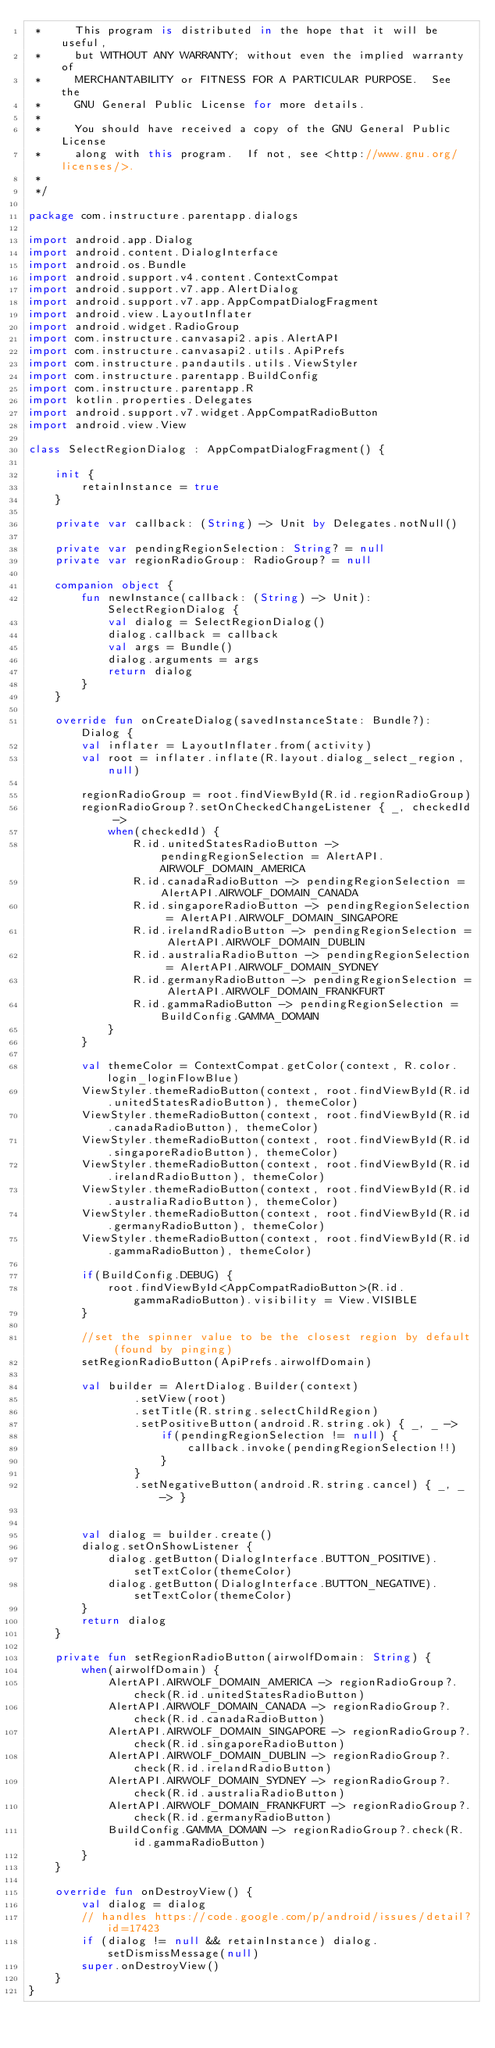<code> <loc_0><loc_0><loc_500><loc_500><_Kotlin_> *     This program is distributed in the hope that it will be useful,
 *     but WITHOUT ANY WARRANTY; without even the implied warranty of
 *     MERCHANTABILITY or FITNESS FOR A PARTICULAR PURPOSE.  See the
 *     GNU General Public License for more details.
 *
 *     You should have received a copy of the GNU General Public License
 *     along with this program.  If not, see <http://www.gnu.org/licenses/>.
 *
 */

package com.instructure.parentapp.dialogs

import android.app.Dialog
import android.content.DialogInterface
import android.os.Bundle
import android.support.v4.content.ContextCompat
import android.support.v7.app.AlertDialog
import android.support.v7.app.AppCompatDialogFragment
import android.view.LayoutInflater
import android.widget.RadioGroup
import com.instructure.canvasapi2.apis.AlertAPI
import com.instructure.canvasapi2.utils.ApiPrefs
import com.instructure.pandautils.utils.ViewStyler
import com.instructure.parentapp.BuildConfig
import com.instructure.parentapp.R
import kotlin.properties.Delegates
import android.support.v7.widget.AppCompatRadioButton
import android.view.View

class SelectRegionDialog : AppCompatDialogFragment() {

    init {
        retainInstance = true
    }

    private var callback: (String) -> Unit by Delegates.notNull()

    private var pendingRegionSelection: String? = null
    private var regionRadioGroup: RadioGroup? = null

    companion object {
        fun newInstance(callback: (String) -> Unit): SelectRegionDialog {
            val dialog = SelectRegionDialog()
            dialog.callback = callback
            val args = Bundle()
            dialog.arguments = args
            return dialog
        }
    }

    override fun onCreateDialog(savedInstanceState: Bundle?): Dialog {
        val inflater = LayoutInflater.from(activity)
        val root = inflater.inflate(R.layout.dialog_select_region, null)

        regionRadioGroup = root.findViewById(R.id.regionRadioGroup)
        regionRadioGroup?.setOnCheckedChangeListener { _, checkedId ->
            when(checkedId) {
                R.id.unitedStatesRadioButton -> pendingRegionSelection = AlertAPI.AIRWOLF_DOMAIN_AMERICA
                R.id.canadaRadioButton -> pendingRegionSelection = AlertAPI.AIRWOLF_DOMAIN_CANADA
                R.id.singaporeRadioButton -> pendingRegionSelection = AlertAPI.AIRWOLF_DOMAIN_SINGAPORE
                R.id.irelandRadioButton -> pendingRegionSelection = AlertAPI.AIRWOLF_DOMAIN_DUBLIN
                R.id.australiaRadioButton -> pendingRegionSelection = AlertAPI.AIRWOLF_DOMAIN_SYDNEY
                R.id.germanyRadioButton -> pendingRegionSelection = AlertAPI.AIRWOLF_DOMAIN_FRANKFURT
                R.id.gammaRadioButton -> pendingRegionSelection = BuildConfig.GAMMA_DOMAIN
            }
        }

        val themeColor = ContextCompat.getColor(context, R.color.login_loginFlowBlue)
        ViewStyler.themeRadioButton(context, root.findViewById(R.id.unitedStatesRadioButton), themeColor)
        ViewStyler.themeRadioButton(context, root.findViewById(R.id.canadaRadioButton), themeColor)
        ViewStyler.themeRadioButton(context, root.findViewById(R.id.singaporeRadioButton), themeColor)
        ViewStyler.themeRadioButton(context, root.findViewById(R.id.irelandRadioButton), themeColor)
        ViewStyler.themeRadioButton(context, root.findViewById(R.id.australiaRadioButton), themeColor)
        ViewStyler.themeRadioButton(context, root.findViewById(R.id.germanyRadioButton), themeColor)
        ViewStyler.themeRadioButton(context, root.findViewById(R.id.gammaRadioButton), themeColor)

        if(BuildConfig.DEBUG) {
            root.findViewById<AppCompatRadioButton>(R.id.gammaRadioButton).visibility = View.VISIBLE
        }

        //set the spinner value to be the closest region by default (found by pinging)
        setRegionRadioButton(ApiPrefs.airwolfDomain)

        val builder = AlertDialog.Builder(context)
                .setView(root)
                .setTitle(R.string.selectChildRegion)
                .setPositiveButton(android.R.string.ok) { _, _ ->
                    if(pendingRegionSelection != null) {
                        callback.invoke(pendingRegionSelection!!)
                    }
                }
                .setNegativeButton(android.R.string.cancel) { _, _ -> }


        val dialog = builder.create()
        dialog.setOnShowListener {
            dialog.getButton(DialogInterface.BUTTON_POSITIVE).setTextColor(themeColor)
            dialog.getButton(DialogInterface.BUTTON_NEGATIVE).setTextColor(themeColor)
        }
        return dialog
    }

    private fun setRegionRadioButton(airwolfDomain: String) {
        when(airwolfDomain) {
            AlertAPI.AIRWOLF_DOMAIN_AMERICA -> regionRadioGroup?.check(R.id.unitedStatesRadioButton)
            AlertAPI.AIRWOLF_DOMAIN_CANADA -> regionRadioGroup?.check(R.id.canadaRadioButton)
            AlertAPI.AIRWOLF_DOMAIN_SINGAPORE -> regionRadioGroup?.check(R.id.singaporeRadioButton)
            AlertAPI.AIRWOLF_DOMAIN_DUBLIN -> regionRadioGroup?.check(R.id.irelandRadioButton)
            AlertAPI.AIRWOLF_DOMAIN_SYDNEY -> regionRadioGroup?.check(R.id.australiaRadioButton)
            AlertAPI.AIRWOLF_DOMAIN_FRANKFURT -> regionRadioGroup?.check(R.id.germanyRadioButton)
            BuildConfig.GAMMA_DOMAIN -> regionRadioGroup?.check(R.id.gammaRadioButton)
        }
    }

    override fun onDestroyView() {
        val dialog = dialog
        // handles https://code.google.com/p/android/issues/detail?id=17423
        if (dialog != null && retainInstance) dialog.setDismissMessage(null)
        super.onDestroyView()
    }
}
</code> 